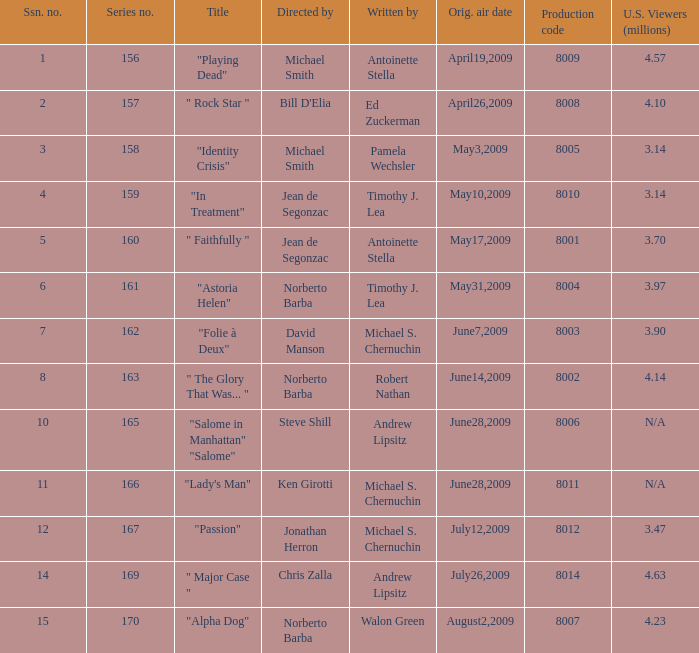Can you give me this table as a dict? {'header': ['Ssn. no.', 'Series no.', 'Title', 'Directed by', 'Written by', 'Orig. air date', 'Production code', 'U.S. Viewers (millions)'], 'rows': [['1', '156', '"Playing Dead"', 'Michael Smith', 'Antoinette Stella', 'April19,2009', '8009', '4.57'], ['2', '157', '" Rock Star "', "Bill D'Elia", 'Ed Zuckerman', 'April26,2009', '8008', '4.10'], ['3', '158', '"Identity Crisis"', 'Michael Smith', 'Pamela Wechsler', 'May3,2009', '8005', '3.14'], ['4', '159', '"In Treatment"', 'Jean de Segonzac', 'Timothy J. Lea', 'May10,2009', '8010', '3.14'], ['5', '160', '" Faithfully "', 'Jean de Segonzac', 'Antoinette Stella', 'May17,2009', '8001', '3.70'], ['6', '161', '"Astoria Helen"', 'Norberto Barba', 'Timothy J. Lea', 'May31,2009', '8004', '3.97'], ['7', '162', '"Folie à Deux"', 'David Manson', 'Michael S. Chernuchin', 'June7,2009', '8003', '3.90'], ['8', '163', '" The Glory That Was... "', 'Norberto Barba', 'Robert Nathan', 'June14,2009', '8002', '4.14'], ['10', '165', '"Salome in Manhattan" "Salome"', 'Steve Shill', 'Andrew Lipsitz', 'June28,2009', '8006', 'N/A'], ['11', '166', '"Lady\'s Man"', 'Ken Girotti', 'Michael S. Chernuchin', 'June28,2009', '8011', 'N/A'], ['12', '167', '"Passion"', 'Jonathan Herron', 'Michael S. Chernuchin', 'July12,2009', '8012', '3.47'], ['14', '169', '" Major Case "', 'Chris Zalla', 'Andrew Lipsitz', 'July26,2009', '8014', '4.63'], ['15', '170', '"Alpha Dog"', 'Norberto Barba', 'Walon Green', 'August2,2009', '8007', '4.23']]} Which is the  maximun serie episode number when the millions of north american spectators is 3.14? 159.0. 